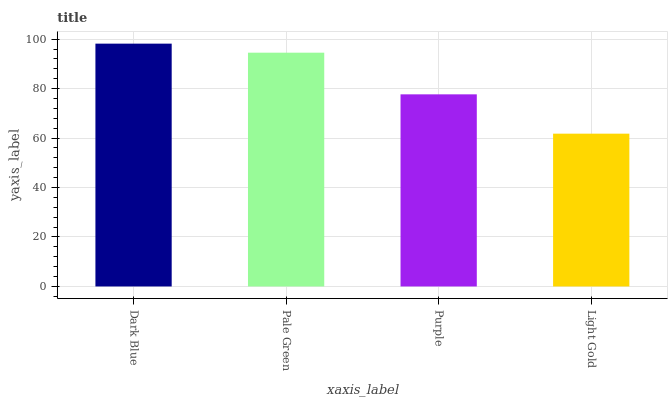Is Light Gold the minimum?
Answer yes or no. Yes. Is Dark Blue the maximum?
Answer yes or no. Yes. Is Pale Green the minimum?
Answer yes or no. No. Is Pale Green the maximum?
Answer yes or no. No. Is Dark Blue greater than Pale Green?
Answer yes or no. Yes. Is Pale Green less than Dark Blue?
Answer yes or no. Yes. Is Pale Green greater than Dark Blue?
Answer yes or no. No. Is Dark Blue less than Pale Green?
Answer yes or no. No. Is Pale Green the high median?
Answer yes or no. Yes. Is Purple the low median?
Answer yes or no. Yes. Is Purple the high median?
Answer yes or no. No. Is Dark Blue the low median?
Answer yes or no. No. 